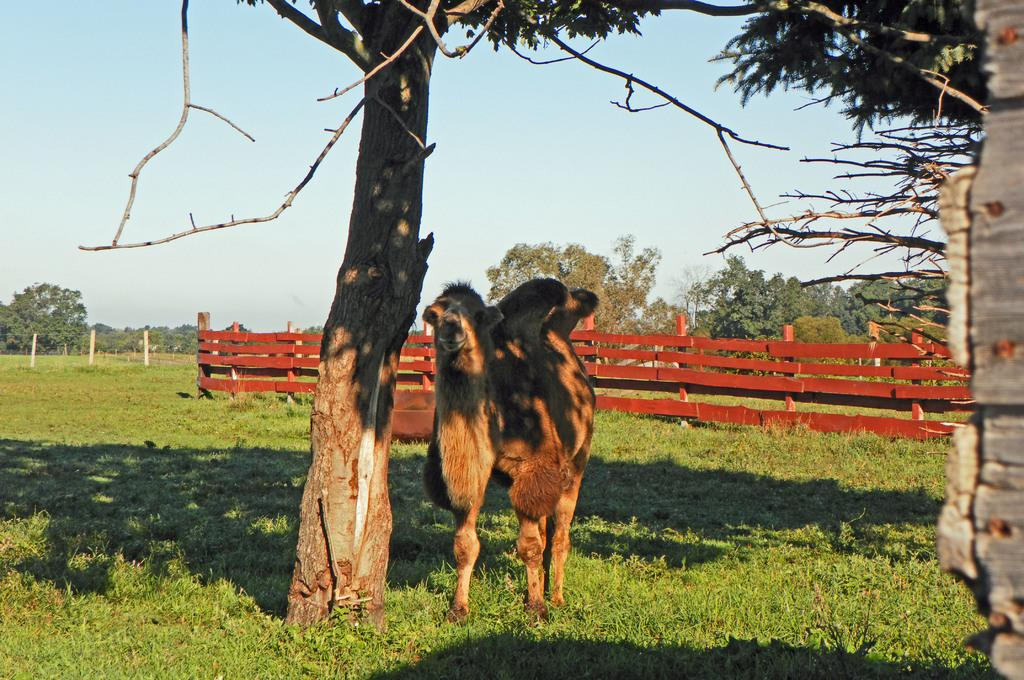What is the main subject in the center of the image? There is a camel in the center of the image. What can be seen in the background of the image? There is a fence and trees in the background of the image. What type of vegetation is at the bottom of the image? There is grass at the bottom of the image. What is visible at the top of the image? The sky is visible at the top of the image. Where is the jail located in the image? There is no jail present in the image. Can you see any islands in the image? There are no islands visible in the image. 